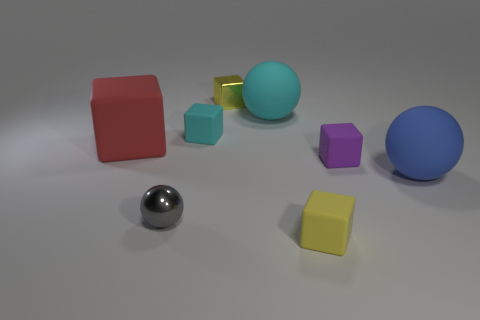There is a yellow cube that is to the left of the cyan sphere; is it the same size as the yellow thing in front of the large red rubber thing?
Make the answer very short. Yes. What number of things are either red cylinders or tiny purple matte blocks?
Your answer should be compact. 1. The small yellow thing that is on the left side of the yellow thing in front of the small yellow metal thing is made of what material?
Offer a very short reply. Metal. What number of tiny purple rubber things are the same shape as the gray thing?
Offer a very short reply. 0. Is there a object of the same color as the metal ball?
Keep it short and to the point. No. What number of objects are tiny cubes to the left of the yellow matte cube or tiny yellow cubes behind the big red thing?
Make the answer very short. 2. There is a large rubber thing that is left of the tiny gray ball; are there any blocks that are in front of it?
Your response must be concise. Yes. There is a cyan rubber thing that is the same size as the red rubber block; what shape is it?
Your response must be concise. Sphere. How many things are large rubber things that are behind the purple rubber thing or blue balls?
Offer a terse response. 3. What number of other things are there of the same material as the tiny sphere
Your answer should be compact. 1. 